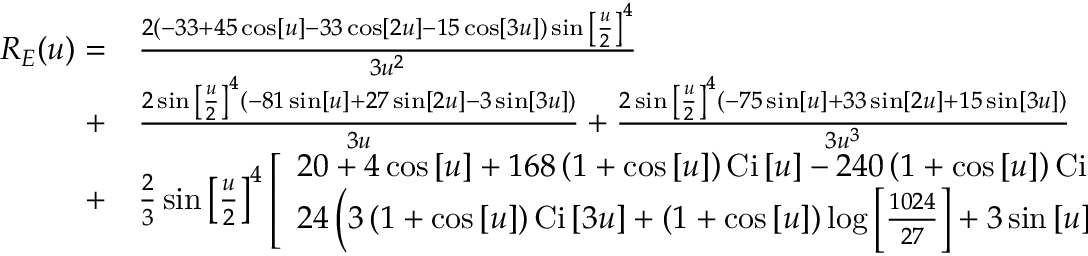<formula> <loc_0><loc_0><loc_500><loc_500>\begin{array} { r l } { { R _ { E } } ( u ) = } & \frac { { 2 \left ( { - 3 3 + 4 5 \cos \left [ u \right ] - 3 3 \cos \left [ { 2 u } \right ] - 1 5 \cos \left [ { 3 u } \right ] } \right ) \sin { { \left [ { \frac { u } { 2 } } \right ] } ^ { 4 } } } } { { 3 { u ^ { 2 } } } } } \\ { + } & \frac { { 2 \sin { { \left [ { \frac { u } { 2 } } \right ] } ^ { 4 } } \left ( { - 8 1 \sin \left [ u \right ] + 2 7 \sin \left [ { 2 u } \right ] - 3 \sin \left [ { 3 u } \right ] } \right ) } } { 3 u } + \frac { { 2 \sin { { \left [ { \frac { u } { 2 } } \right ] } ^ { 4 } } \left ( { - 7 5 \sin \left [ u \right ] + 3 3 \sin \left [ { 2 u } \right ] + 1 5 \sin \left [ { 3 u } \right ] } \right ) } } { { 3 { u ^ { 3 } } } } } \\ { + } & \frac { 2 } { 3 } \sin { \left [ { \frac { u } { 2 } } \right ] ^ { 4 } } \left [ \begin{array} { l } { 2 0 + 4 \cos \left [ u \right ] + 1 6 8 \left ( { 1 + \cos \left [ u \right ] } \right ) { C i } \left [ u \right ] - 2 4 0 \left ( { 1 + \cos \left [ u \right ] } \right ) { C i } \left [ { 2 u } \right ] + } \\ { 2 4 \left ( { 3 \left ( { 1 + \cos \left [ u \right ] } \right ) { C i } \left [ { 3 u } \right ] + \left ( { 1 + \cos \left [ u \right ] } \right ) \log \left [ { \frac { 1 0 2 4 } { 2 7 } } \right ] + 3 \sin \left [ u \right ] \left ( { { S i } \left [ u \right ] - 2 { S i } \left [ { 2 u } \right ] + { S i } \left [ { 3 u } \right ] } \right ) } \right ) } \end{array} \right ] . } \end{array}</formula> 